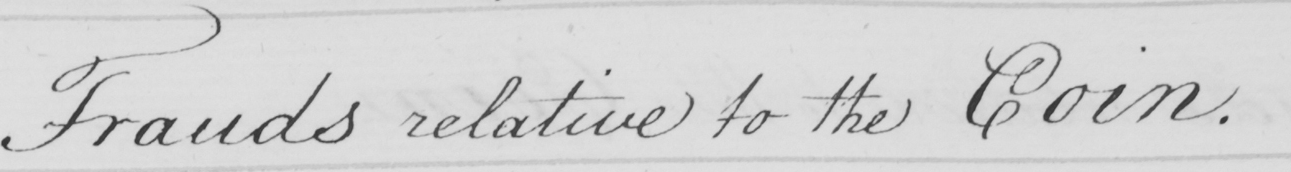Can you read and transcribe this handwriting? Frauds relative to the Coin. 